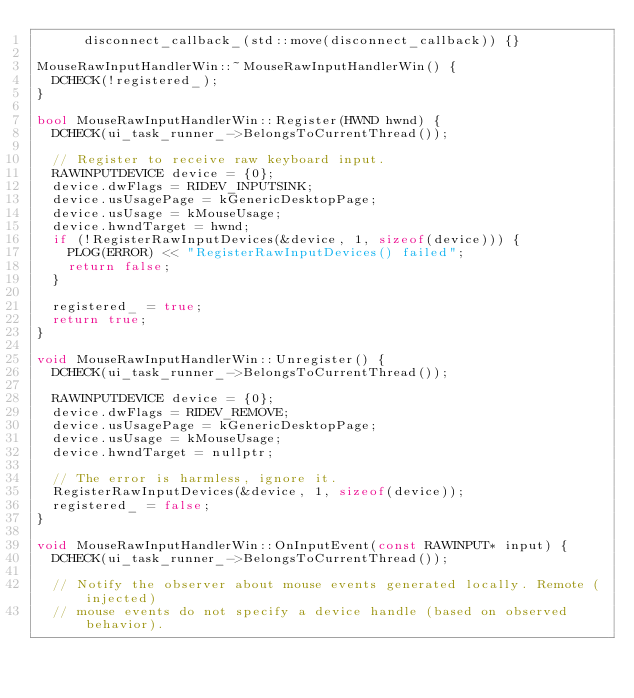Convert code to text. <code><loc_0><loc_0><loc_500><loc_500><_C++_>      disconnect_callback_(std::move(disconnect_callback)) {}

MouseRawInputHandlerWin::~MouseRawInputHandlerWin() {
  DCHECK(!registered_);
}

bool MouseRawInputHandlerWin::Register(HWND hwnd) {
  DCHECK(ui_task_runner_->BelongsToCurrentThread());

  // Register to receive raw keyboard input.
  RAWINPUTDEVICE device = {0};
  device.dwFlags = RIDEV_INPUTSINK;
  device.usUsagePage = kGenericDesktopPage;
  device.usUsage = kMouseUsage;
  device.hwndTarget = hwnd;
  if (!RegisterRawInputDevices(&device, 1, sizeof(device))) {
    PLOG(ERROR) << "RegisterRawInputDevices() failed";
    return false;
  }

  registered_ = true;
  return true;
}

void MouseRawInputHandlerWin::Unregister() {
  DCHECK(ui_task_runner_->BelongsToCurrentThread());

  RAWINPUTDEVICE device = {0};
  device.dwFlags = RIDEV_REMOVE;
  device.usUsagePage = kGenericDesktopPage;
  device.usUsage = kMouseUsage;
  device.hwndTarget = nullptr;

  // The error is harmless, ignore it.
  RegisterRawInputDevices(&device, 1, sizeof(device));
  registered_ = false;
}

void MouseRawInputHandlerWin::OnInputEvent(const RAWINPUT* input) {
  DCHECK(ui_task_runner_->BelongsToCurrentThread());

  // Notify the observer about mouse events generated locally. Remote (injected)
  // mouse events do not specify a device handle (based on observed behavior).</code> 